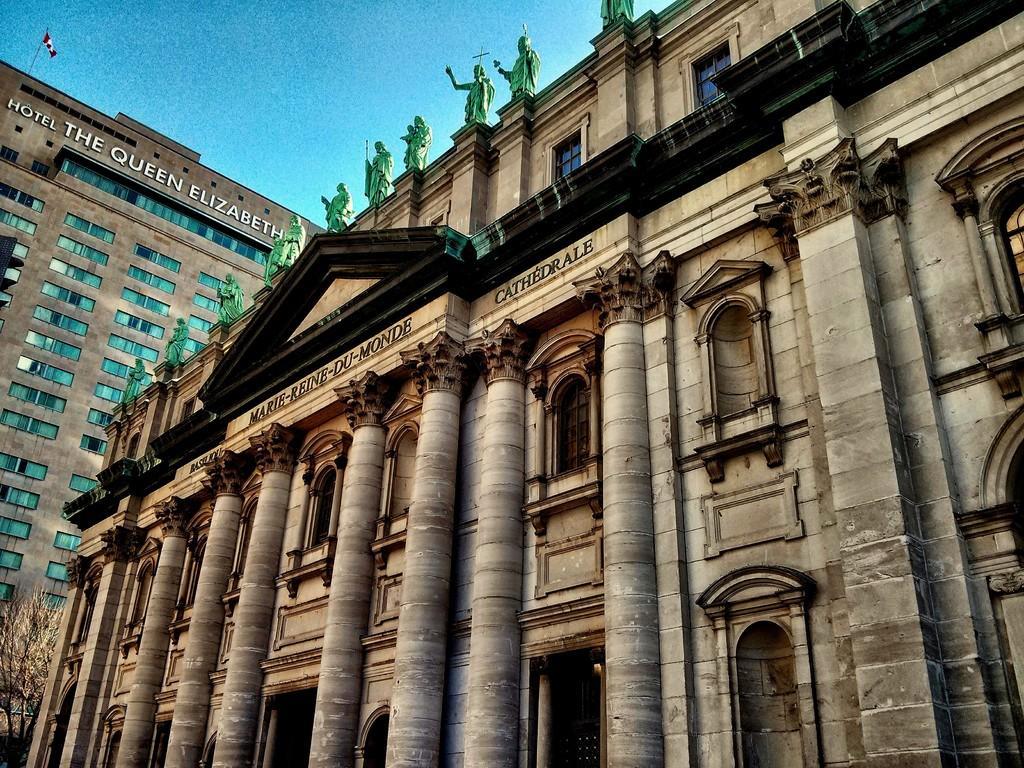Please provide a concise description of this image. In this image there are buildings and in the front on the top of the building there are statues and there is some text written on the wall of the building and in the background of the building there is some text written on the wall and on the top there is a flag and there is a tree in front of the building. 